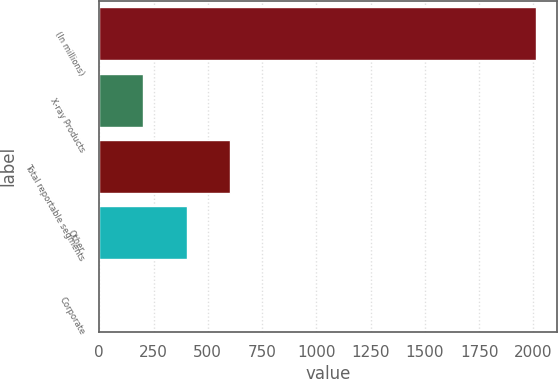<chart> <loc_0><loc_0><loc_500><loc_500><bar_chart><fcel>(In millions)<fcel>X-ray Products<fcel>Total reportable segments<fcel>Other<fcel>Corporate<nl><fcel>2010<fcel>202.03<fcel>603.8<fcel>402.91<fcel>1.15<nl></chart> 